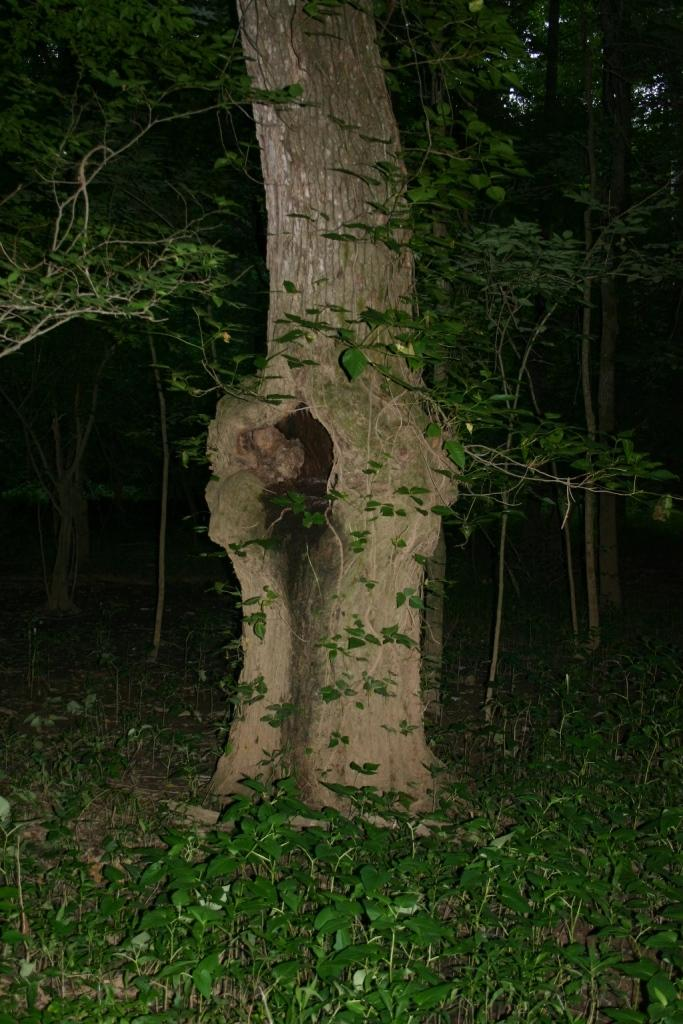What is the main subject in the middle of the image? There is a tree trunk in the middle of the image. What can be seen at the bottom of the image? There are plants at the bottom of the image. What type of vegetation is visible in the background of the image? There are trees visible in the background of the image. What type of sail can be seen on the tree trunk in the image? There is no sail present on the tree trunk in the image. What is the aftermath of the storm in the image? There is no storm or aftermath mentioned in the image; it only features a tree trunk, plants, and trees. 